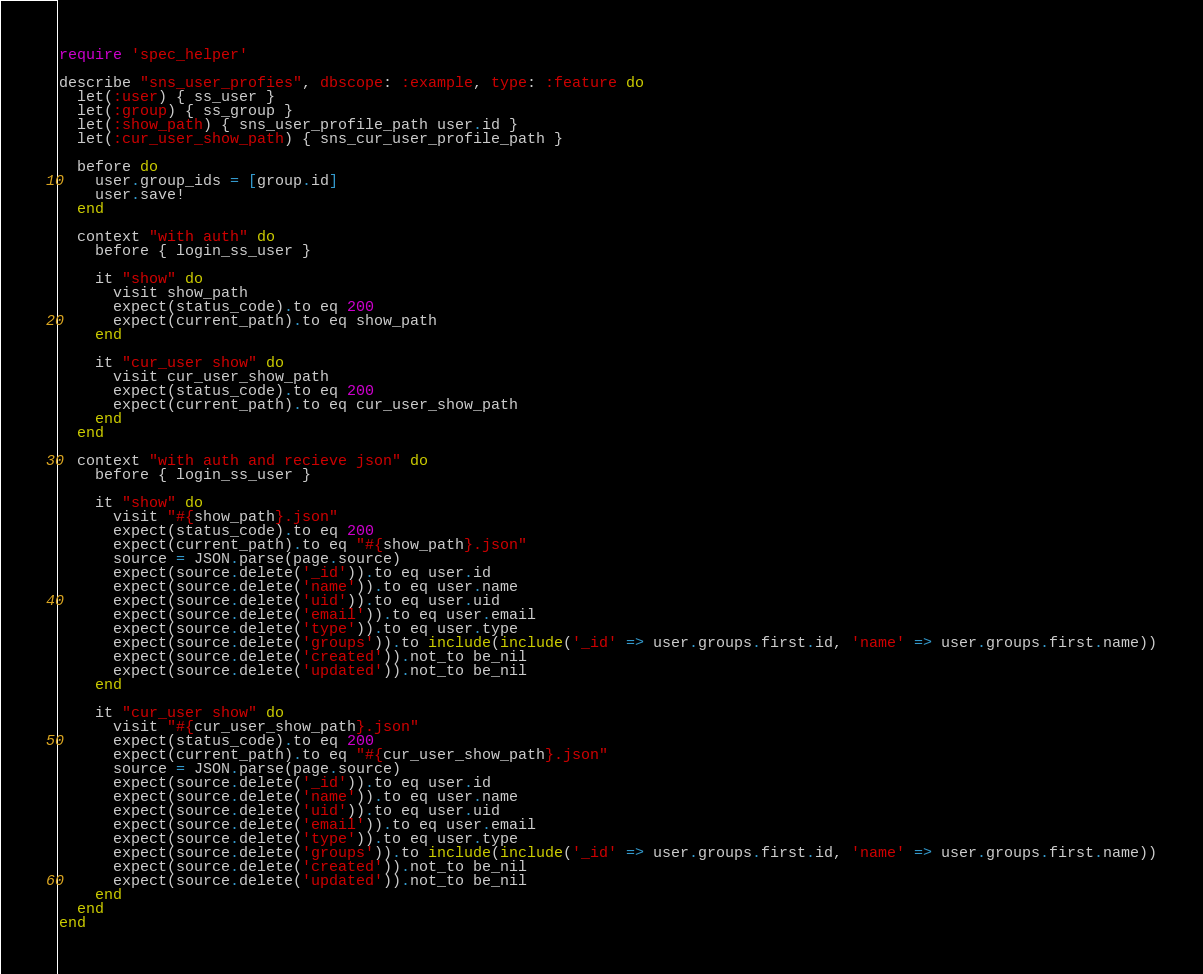<code> <loc_0><loc_0><loc_500><loc_500><_Ruby_>require 'spec_helper'

describe "sns_user_profies", dbscope: :example, type: :feature do
  let(:user) { ss_user }
  let(:group) { ss_group }
  let(:show_path) { sns_user_profile_path user.id }
  let(:cur_user_show_path) { sns_cur_user_profile_path }

  before do
    user.group_ids = [group.id]
    user.save!
  end

  context "with auth" do
    before { login_ss_user }

    it "show" do
      visit show_path
      expect(status_code).to eq 200
      expect(current_path).to eq show_path
    end

    it "cur_user show" do
      visit cur_user_show_path
      expect(status_code).to eq 200
      expect(current_path).to eq cur_user_show_path
    end
  end

  context "with auth and recieve json" do
    before { login_ss_user }

    it "show" do
      visit "#{show_path}.json"
      expect(status_code).to eq 200
      expect(current_path).to eq "#{show_path}.json"
      source = JSON.parse(page.source)
      expect(source.delete('_id')).to eq user.id
      expect(source.delete('name')).to eq user.name
      expect(source.delete('uid')).to eq user.uid
      expect(source.delete('email')).to eq user.email
      expect(source.delete('type')).to eq user.type
      expect(source.delete('groups')).to include(include('_id' => user.groups.first.id, 'name' => user.groups.first.name))
      expect(source.delete('created')).not_to be_nil
      expect(source.delete('updated')).not_to be_nil
    end

    it "cur_user show" do
      visit "#{cur_user_show_path}.json"
      expect(status_code).to eq 200
      expect(current_path).to eq "#{cur_user_show_path}.json"
      source = JSON.parse(page.source)
      expect(source.delete('_id')).to eq user.id
      expect(source.delete('name')).to eq user.name
      expect(source.delete('uid')).to eq user.uid
      expect(source.delete('email')).to eq user.email
      expect(source.delete('type')).to eq user.type
      expect(source.delete('groups')).to include(include('_id' => user.groups.first.id, 'name' => user.groups.first.name))
      expect(source.delete('created')).not_to be_nil
      expect(source.delete('updated')).not_to be_nil
    end
  end
end
</code> 